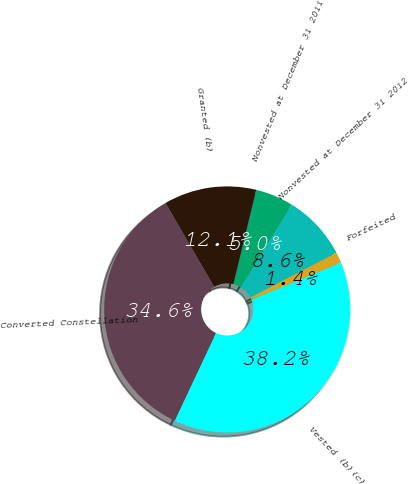<chart> <loc_0><loc_0><loc_500><loc_500><pie_chart><fcel>Nonvested at December 31 2011<fcel>Granted (b)<fcel>Converted Constellation<fcel>Vested (b)(c)<fcel>Forfeited<fcel>Nonvested at December 31 2012<nl><fcel>5.0%<fcel>12.15%<fcel>34.64%<fcel>38.21%<fcel>1.42%<fcel>8.58%<nl></chart> 